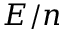<formula> <loc_0><loc_0><loc_500><loc_500>E / n</formula> 